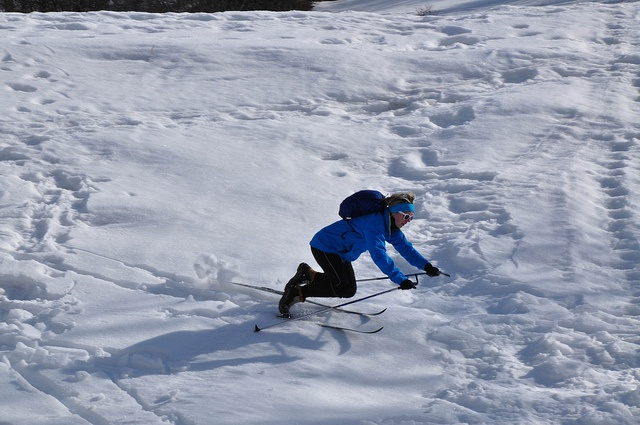Describe the objects in this image and their specific colors. I can see people in black, navy, darkblue, and blue tones, backpack in black, navy, lightgray, and darkgray tones, and skis in black, darkgray, and gray tones in this image. 